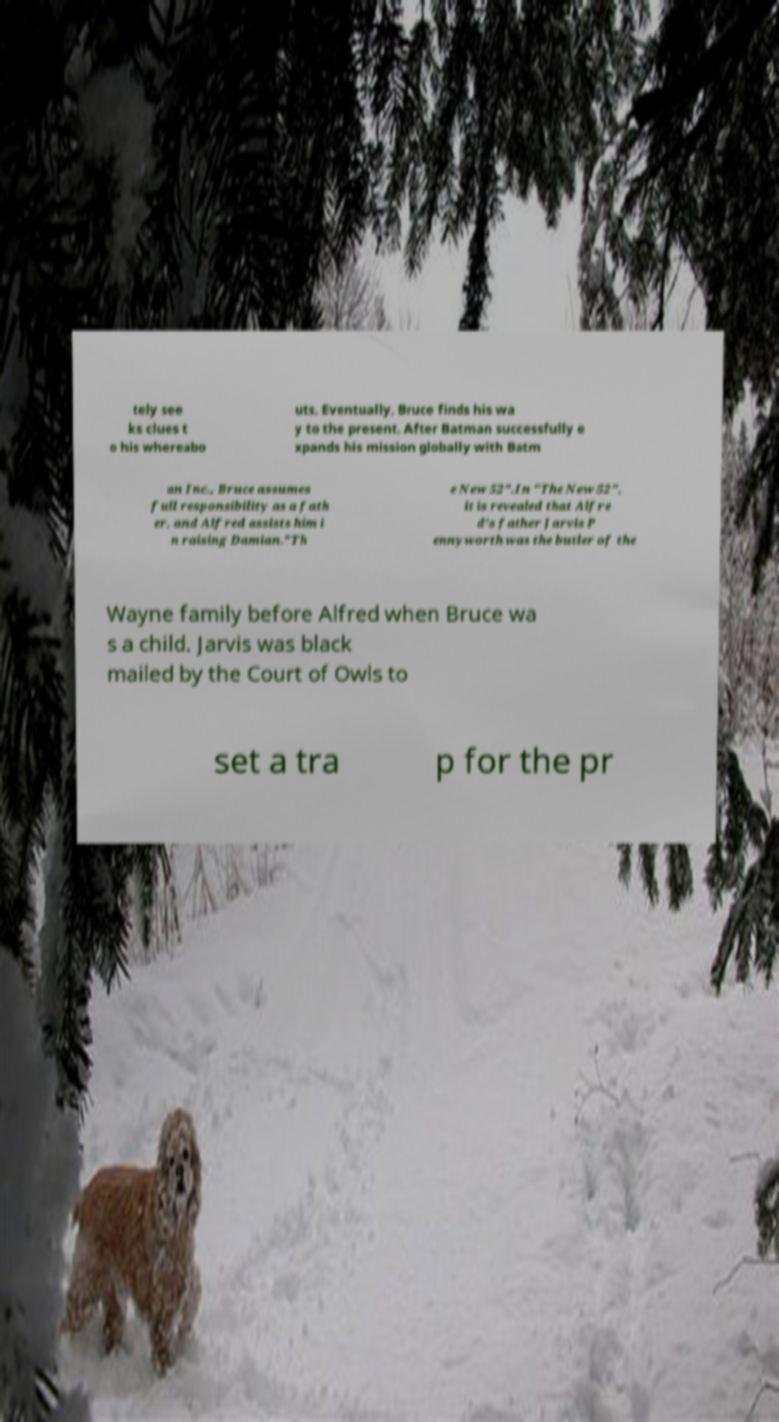Please identify and transcribe the text found in this image. tely see ks clues t o his whereabo uts. Eventually, Bruce finds his wa y to the present. After Batman successfully e xpands his mission globally with Batm an Inc., Bruce assumes full responsibility as a fath er, and Alfred assists him i n raising Damian."Th e New 52".In "The New 52", it is revealed that Alfre d's father Jarvis P ennyworth was the butler of the Wayne family before Alfred when Bruce wa s a child. Jarvis was black mailed by the Court of Owls to set a tra p for the pr 